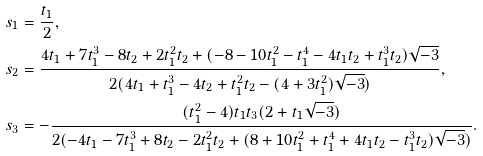Convert formula to latex. <formula><loc_0><loc_0><loc_500><loc_500>s _ { 1 } & = \frac { t _ { 1 } } { 2 } , \\ s _ { 2 } & = \frac { 4 t _ { 1 } + 7 t _ { 1 } ^ { 3 } - 8 t _ { 2 } + 2 t _ { 1 } ^ { 2 } t _ { 2 } + ( - 8 - 1 0 t _ { 1 } ^ { 2 } - t _ { 1 } ^ { 4 } - 4 t _ { 1 } t _ { 2 } + t _ { 1 } ^ { 3 } t _ { 2 } ) \sqrt { - 3 } } { 2 ( 4 t _ { 1 } + t _ { 1 } ^ { 3 } - 4 t _ { 2 } + t _ { 1 } ^ { 2 } t _ { 2 } - ( 4 + 3 t _ { 1 } ^ { 2 } ) \sqrt { - 3 } ) } , \\ s _ { 3 } & = - \frac { ( t _ { 1 } ^ { 2 } - 4 ) t _ { 1 } t _ { 3 } ( 2 + t _ { 1 } \sqrt { - 3 } ) } { 2 ( - 4 t _ { 1 } - 7 t _ { 1 } ^ { 3 } + 8 t _ { 2 } - 2 t _ { 1 } ^ { 2 } t _ { 2 } + ( 8 + 1 0 t _ { 1 } ^ { 2 } + t _ { 1 } ^ { 4 } + 4 t _ { 1 } t _ { 2 } - t _ { 1 } ^ { 3 } t _ { 2 } ) \sqrt { - 3 } ) } .</formula> 